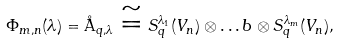Convert formula to latex. <formula><loc_0><loc_0><loc_500><loc_500>\Phi _ { m , n } ( \lambda ) = \AA _ { q , \lambda } \cong S _ { q } ^ { \lambda _ { 1 } } ( V _ { n } ) \otimes \dots b \otimes S _ { q } ^ { \lambda _ { m } } ( V _ { n } ) ,</formula> 